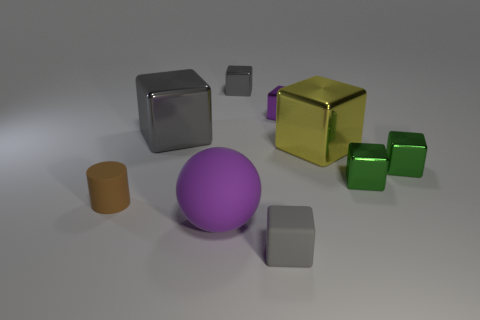There is a rubber cube; is it the same color as the shiny block on the left side of the large rubber ball?
Offer a very short reply. Yes. What number of other things are the same size as the cylinder?
Ensure brevity in your answer.  5. Does the small brown thing have the same material as the big thing to the right of the tiny purple cube?
Offer a very short reply. No. Are there an equal number of large yellow shiny blocks that are left of the small purple cube and yellow shiny blocks right of the small brown matte cylinder?
Provide a short and direct response. No. What is the tiny purple cube made of?
Ensure brevity in your answer.  Metal. What color is the matte object that is the same size as the brown cylinder?
Ensure brevity in your answer.  Gray. There is a large shiny block to the left of the yellow thing; are there any small gray cubes that are behind it?
Ensure brevity in your answer.  Yes. How many cylinders are either big shiny things or yellow things?
Your response must be concise. 0. What is the size of the gray object right of the small gray cube behind the thing in front of the purple matte thing?
Offer a very short reply. Small. There is a rubber block; are there any big cubes right of it?
Your answer should be compact. Yes. 